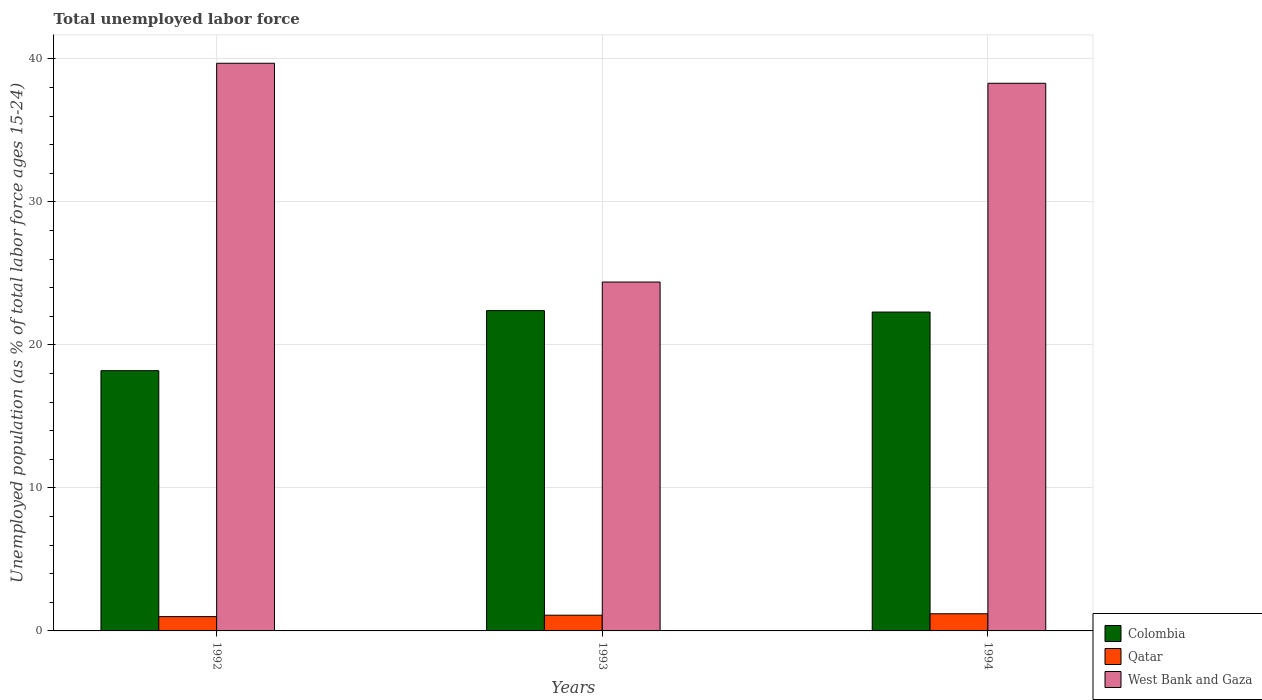How many different coloured bars are there?
Your answer should be compact. 3. Are the number of bars on each tick of the X-axis equal?
Offer a very short reply. Yes. In how many cases, is the number of bars for a given year not equal to the number of legend labels?
Make the answer very short. 0. What is the percentage of unemployed population in in Qatar in 1992?
Give a very brief answer. 1. Across all years, what is the maximum percentage of unemployed population in in West Bank and Gaza?
Offer a very short reply. 39.7. In which year was the percentage of unemployed population in in West Bank and Gaza maximum?
Offer a very short reply. 1992. In which year was the percentage of unemployed population in in West Bank and Gaza minimum?
Keep it short and to the point. 1993. What is the total percentage of unemployed population in in Colombia in the graph?
Keep it short and to the point. 62.9. What is the difference between the percentage of unemployed population in in Colombia in 1992 and that in 1993?
Offer a terse response. -4.2. What is the difference between the percentage of unemployed population in in Qatar in 1993 and the percentage of unemployed population in in Colombia in 1994?
Keep it short and to the point. -21.2. What is the average percentage of unemployed population in in West Bank and Gaza per year?
Keep it short and to the point. 34.13. In the year 1992, what is the difference between the percentage of unemployed population in in Colombia and percentage of unemployed population in in West Bank and Gaza?
Offer a very short reply. -21.5. In how many years, is the percentage of unemployed population in in Qatar greater than 18 %?
Provide a short and direct response. 0. What is the ratio of the percentage of unemployed population in in Colombia in 1993 to that in 1994?
Make the answer very short. 1. Is the difference between the percentage of unemployed population in in Colombia in 1992 and 1994 greater than the difference between the percentage of unemployed population in in West Bank and Gaza in 1992 and 1994?
Your answer should be very brief. No. What is the difference between the highest and the second highest percentage of unemployed population in in Qatar?
Provide a succinct answer. 0.1. What is the difference between the highest and the lowest percentage of unemployed population in in Qatar?
Make the answer very short. 0.2. What does the 2nd bar from the left in 1992 represents?
Your answer should be very brief. Qatar. What does the 1st bar from the right in 1994 represents?
Ensure brevity in your answer.  West Bank and Gaza. Is it the case that in every year, the sum of the percentage of unemployed population in in West Bank and Gaza and percentage of unemployed population in in Qatar is greater than the percentage of unemployed population in in Colombia?
Your answer should be compact. Yes. Does the graph contain any zero values?
Make the answer very short. No. Where does the legend appear in the graph?
Your response must be concise. Bottom right. How many legend labels are there?
Your response must be concise. 3. What is the title of the graph?
Give a very brief answer. Total unemployed labor force. Does "Cameroon" appear as one of the legend labels in the graph?
Give a very brief answer. No. What is the label or title of the X-axis?
Provide a short and direct response. Years. What is the label or title of the Y-axis?
Your answer should be very brief. Unemployed population (as % of total labor force ages 15-24). What is the Unemployed population (as % of total labor force ages 15-24) of Colombia in 1992?
Offer a terse response. 18.2. What is the Unemployed population (as % of total labor force ages 15-24) of West Bank and Gaza in 1992?
Your response must be concise. 39.7. What is the Unemployed population (as % of total labor force ages 15-24) of Colombia in 1993?
Make the answer very short. 22.4. What is the Unemployed population (as % of total labor force ages 15-24) of Qatar in 1993?
Offer a terse response. 1.1. What is the Unemployed population (as % of total labor force ages 15-24) of West Bank and Gaza in 1993?
Provide a short and direct response. 24.4. What is the Unemployed population (as % of total labor force ages 15-24) in Colombia in 1994?
Give a very brief answer. 22.3. What is the Unemployed population (as % of total labor force ages 15-24) in Qatar in 1994?
Your answer should be compact. 1.2. What is the Unemployed population (as % of total labor force ages 15-24) in West Bank and Gaza in 1994?
Keep it short and to the point. 38.3. Across all years, what is the maximum Unemployed population (as % of total labor force ages 15-24) of Colombia?
Provide a succinct answer. 22.4. Across all years, what is the maximum Unemployed population (as % of total labor force ages 15-24) in Qatar?
Your answer should be compact. 1.2. Across all years, what is the maximum Unemployed population (as % of total labor force ages 15-24) in West Bank and Gaza?
Give a very brief answer. 39.7. Across all years, what is the minimum Unemployed population (as % of total labor force ages 15-24) of Colombia?
Offer a terse response. 18.2. Across all years, what is the minimum Unemployed population (as % of total labor force ages 15-24) of Qatar?
Offer a very short reply. 1. Across all years, what is the minimum Unemployed population (as % of total labor force ages 15-24) in West Bank and Gaza?
Offer a terse response. 24.4. What is the total Unemployed population (as % of total labor force ages 15-24) in Colombia in the graph?
Offer a very short reply. 62.9. What is the total Unemployed population (as % of total labor force ages 15-24) in West Bank and Gaza in the graph?
Provide a short and direct response. 102.4. What is the difference between the Unemployed population (as % of total labor force ages 15-24) of Colombia in 1992 and that in 1993?
Give a very brief answer. -4.2. What is the difference between the Unemployed population (as % of total labor force ages 15-24) in West Bank and Gaza in 1992 and that in 1993?
Provide a short and direct response. 15.3. What is the difference between the Unemployed population (as % of total labor force ages 15-24) in Colombia in 1993 and that in 1994?
Offer a terse response. 0.1. What is the difference between the Unemployed population (as % of total labor force ages 15-24) in Qatar in 1993 and that in 1994?
Provide a short and direct response. -0.1. What is the difference between the Unemployed population (as % of total labor force ages 15-24) in West Bank and Gaza in 1993 and that in 1994?
Provide a short and direct response. -13.9. What is the difference between the Unemployed population (as % of total labor force ages 15-24) in Colombia in 1992 and the Unemployed population (as % of total labor force ages 15-24) in Qatar in 1993?
Give a very brief answer. 17.1. What is the difference between the Unemployed population (as % of total labor force ages 15-24) in Qatar in 1992 and the Unemployed population (as % of total labor force ages 15-24) in West Bank and Gaza in 1993?
Ensure brevity in your answer.  -23.4. What is the difference between the Unemployed population (as % of total labor force ages 15-24) in Colombia in 1992 and the Unemployed population (as % of total labor force ages 15-24) in West Bank and Gaza in 1994?
Offer a terse response. -20.1. What is the difference between the Unemployed population (as % of total labor force ages 15-24) in Qatar in 1992 and the Unemployed population (as % of total labor force ages 15-24) in West Bank and Gaza in 1994?
Give a very brief answer. -37.3. What is the difference between the Unemployed population (as % of total labor force ages 15-24) of Colombia in 1993 and the Unemployed population (as % of total labor force ages 15-24) of Qatar in 1994?
Ensure brevity in your answer.  21.2. What is the difference between the Unemployed population (as % of total labor force ages 15-24) in Colombia in 1993 and the Unemployed population (as % of total labor force ages 15-24) in West Bank and Gaza in 1994?
Provide a short and direct response. -15.9. What is the difference between the Unemployed population (as % of total labor force ages 15-24) of Qatar in 1993 and the Unemployed population (as % of total labor force ages 15-24) of West Bank and Gaza in 1994?
Offer a terse response. -37.2. What is the average Unemployed population (as % of total labor force ages 15-24) in Colombia per year?
Provide a short and direct response. 20.97. What is the average Unemployed population (as % of total labor force ages 15-24) in Qatar per year?
Offer a very short reply. 1.1. What is the average Unemployed population (as % of total labor force ages 15-24) in West Bank and Gaza per year?
Make the answer very short. 34.13. In the year 1992, what is the difference between the Unemployed population (as % of total labor force ages 15-24) in Colombia and Unemployed population (as % of total labor force ages 15-24) in Qatar?
Provide a short and direct response. 17.2. In the year 1992, what is the difference between the Unemployed population (as % of total labor force ages 15-24) in Colombia and Unemployed population (as % of total labor force ages 15-24) in West Bank and Gaza?
Offer a very short reply. -21.5. In the year 1992, what is the difference between the Unemployed population (as % of total labor force ages 15-24) in Qatar and Unemployed population (as % of total labor force ages 15-24) in West Bank and Gaza?
Your response must be concise. -38.7. In the year 1993, what is the difference between the Unemployed population (as % of total labor force ages 15-24) in Colombia and Unemployed population (as % of total labor force ages 15-24) in Qatar?
Your answer should be compact. 21.3. In the year 1993, what is the difference between the Unemployed population (as % of total labor force ages 15-24) in Colombia and Unemployed population (as % of total labor force ages 15-24) in West Bank and Gaza?
Provide a succinct answer. -2. In the year 1993, what is the difference between the Unemployed population (as % of total labor force ages 15-24) of Qatar and Unemployed population (as % of total labor force ages 15-24) of West Bank and Gaza?
Your answer should be compact. -23.3. In the year 1994, what is the difference between the Unemployed population (as % of total labor force ages 15-24) in Colombia and Unemployed population (as % of total labor force ages 15-24) in Qatar?
Ensure brevity in your answer.  21.1. In the year 1994, what is the difference between the Unemployed population (as % of total labor force ages 15-24) of Colombia and Unemployed population (as % of total labor force ages 15-24) of West Bank and Gaza?
Your response must be concise. -16. In the year 1994, what is the difference between the Unemployed population (as % of total labor force ages 15-24) in Qatar and Unemployed population (as % of total labor force ages 15-24) in West Bank and Gaza?
Offer a very short reply. -37.1. What is the ratio of the Unemployed population (as % of total labor force ages 15-24) of Colombia in 1992 to that in 1993?
Ensure brevity in your answer.  0.81. What is the ratio of the Unemployed population (as % of total labor force ages 15-24) in West Bank and Gaza in 1992 to that in 1993?
Provide a short and direct response. 1.63. What is the ratio of the Unemployed population (as % of total labor force ages 15-24) of Colombia in 1992 to that in 1994?
Keep it short and to the point. 0.82. What is the ratio of the Unemployed population (as % of total labor force ages 15-24) in Qatar in 1992 to that in 1994?
Offer a terse response. 0.83. What is the ratio of the Unemployed population (as % of total labor force ages 15-24) of West Bank and Gaza in 1992 to that in 1994?
Make the answer very short. 1.04. What is the ratio of the Unemployed population (as % of total labor force ages 15-24) in Colombia in 1993 to that in 1994?
Ensure brevity in your answer.  1. What is the ratio of the Unemployed population (as % of total labor force ages 15-24) of Qatar in 1993 to that in 1994?
Keep it short and to the point. 0.92. What is the ratio of the Unemployed population (as % of total labor force ages 15-24) in West Bank and Gaza in 1993 to that in 1994?
Offer a very short reply. 0.64. What is the difference between the highest and the second highest Unemployed population (as % of total labor force ages 15-24) in West Bank and Gaza?
Make the answer very short. 1.4. What is the difference between the highest and the lowest Unemployed population (as % of total labor force ages 15-24) in West Bank and Gaza?
Ensure brevity in your answer.  15.3. 